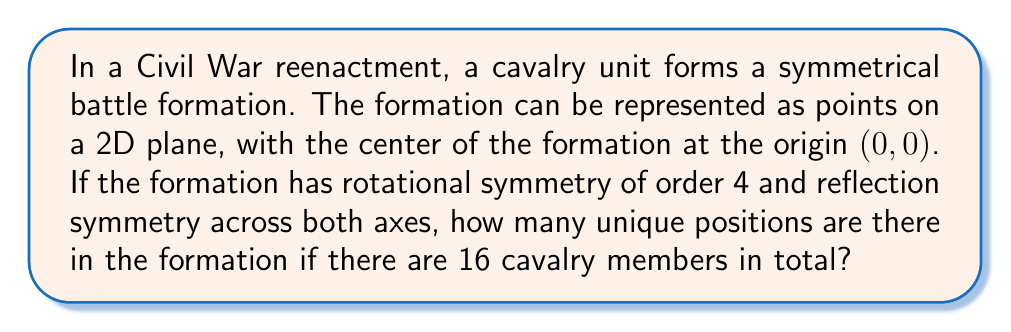Show me your answer to this math problem. Let's approach this step-by-step using group theory and algebraic geometry:

1) The symmetry group of this formation is $D_4$ (Dihedral group of order 8), which includes:
   - Rotations by 0°, 90°, 180°, 270°
   - Reflections across x-axis, y-axis, and both diagonals

2) Each orbit under this group action will have 8 elements, except for special positions:
   - The center (0,0) is fixed by all symmetries (orbit of size 1)
   - Points on the axes (but not at center) have orbits of size 4
   - Points on the diagonals (but not at center) have orbits of size 4

3) Let $n$ be the number of unique positions. Then:

   $$16 = 1 + 4a + 4b + 8n$$

   Where:
   - 1 is the center position
   - $4a$ are positions on the axes (excluding center)
   - $4b$ are positions on the diagonals (excluding center)
   - $8n$ are general positions

4) We need to find the smallest non-negative integer solution for $n$, $a$, and $b$.

5) Rearranging the equation:

   $$15 = 4a + 4b + 8n$$
   $$\frac{15}{4} = a + b + 2n$$

6) The only integer solution satisfying this is $a = 1$, $b = 1$, $n = 1$

Therefore, there are 4 unique positions:
- 1 at the center
- 1 on an axis
- 1 on a diagonal
- 1 in a general position
Answer: 4 